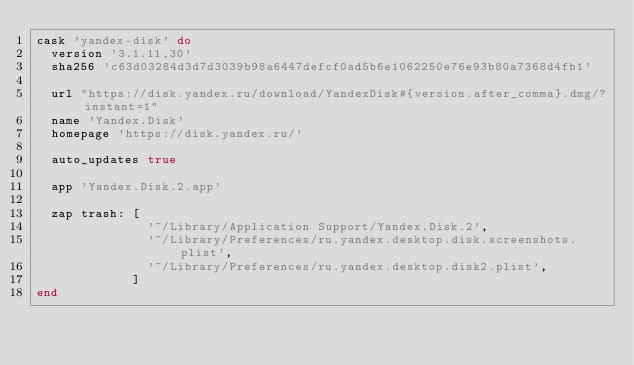<code> <loc_0><loc_0><loc_500><loc_500><_Ruby_>cask 'yandex-disk' do
  version '3.1.11,30'
  sha256 'c63d03284d3d7d3039b98a6447defcf0ad5b6e1062250e76e93b80a7368d4fb1'

  url "https://disk.yandex.ru/download/YandexDisk#{version.after_comma}.dmg/?instant=1"
  name 'Yandex.Disk'
  homepage 'https://disk.yandex.ru/'

  auto_updates true

  app 'Yandex.Disk.2.app'

  zap trash: [
               '~/Library/Application Support/Yandex.Disk.2',
               '~/Library/Preferences/ru.yandex.desktop.disk.screenshots.plist',
               '~/Library/Preferences/ru.yandex.desktop.disk2.plist',
             ]
end
</code> 